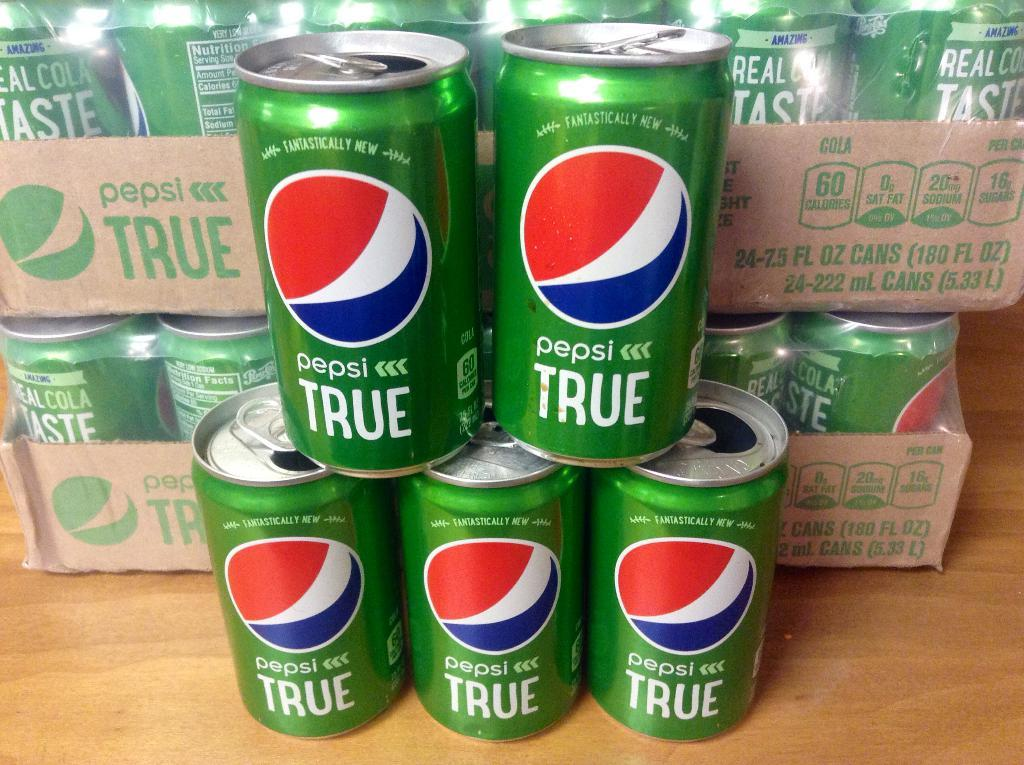<image>
Give a short and clear explanation of the subsequent image. a stack of green and blue pepsi true soda cans 